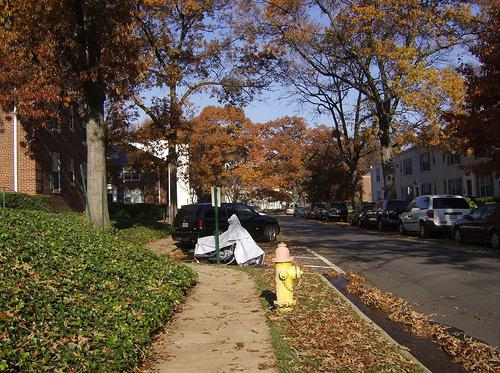What is the most likely reason that the bike is covered where it is? protection 